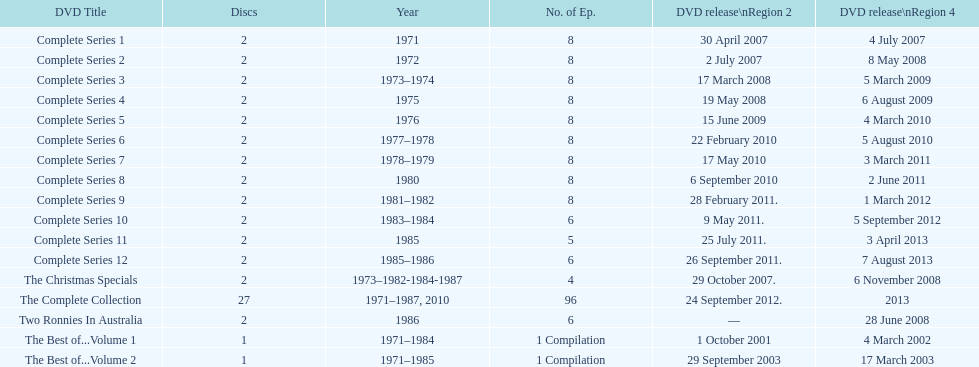What is the number of "best of" volumes that compile the top episodes of the tv show "the two ronnies"? 2. Could you help me parse every detail presented in this table? {'header': ['DVD Title', 'Discs', 'Year', 'No. of Ep.', 'DVD release\\nRegion 2', 'DVD release\\nRegion 4'], 'rows': [['Complete Series 1', '2', '1971', '8', '30 April 2007', '4 July 2007'], ['Complete Series 2', '2', '1972', '8', '2 July 2007', '8 May 2008'], ['Complete Series 3', '2', '1973–1974', '8', '17 March 2008', '5 March 2009'], ['Complete Series 4', '2', '1975', '8', '19 May 2008', '6 August 2009'], ['Complete Series 5', '2', '1976', '8', '15 June 2009', '4 March 2010'], ['Complete Series 6', '2', '1977–1978', '8', '22 February 2010', '5 August 2010'], ['Complete Series 7', '2', '1978–1979', '8', '17 May 2010', '3 March 2011'], ['Complete Series 8', '2', '1980', '8', '6 September 2010', '2 June 2011'], ['Complete Series 9', '2', '1981–1982', '8', '28 February 2011.', '1 March 2012'], ['Complete Series 10', '2', '1983–1984', '6', '9 May 2011.', '5 September 2012'], ['Complete Series 11', '2', '1985', '5', '25 July 2011.', '3 April 2013'], ['Complete Series 12', '2', '1985–1986', '6', '26 September 2011.', '7 August 2013'], ['The Christmas Specials', '2', '1973–1982-1984-1987', '4', '29 October 2007.', '6 November 2008'], ['The Complete Collection', '27', '1971–1987, 2010', '96', '24 September 2012.', '2013'], ['Two Ronnies In Australia', '2', '1986', '6', '—', '28 June 2008'], ['The Best of...Volume 1', '1', '1971–1984', '1 Compilation', '1 October 2001', '4 March 2002'], ['The Best of...Volume 2', '1', '1971–1985', '1 Compilation', '29 September 2003', '17 March 2003']]} 